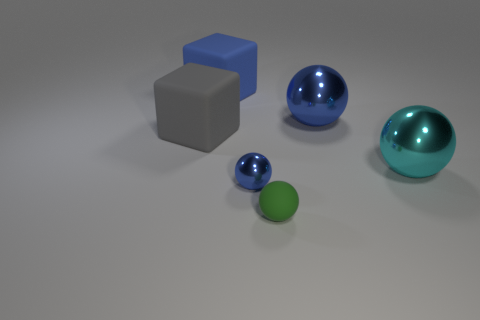Subtract 1 balls. How many balls are left? 3 Add 1 green rubber objects. How many objects exist? 7 Subtract all cubes. How many objects are left? 4 Add 6 big cubes. How many big cubes are left? 8 Add 2 large blue blocks. How many large blue blocks exist? 3 Subtract 0 purple cylinders. How many objects are left? 6 Subtract all cyan shiny things. Subtract all green spheres. How many objects are left? 4 